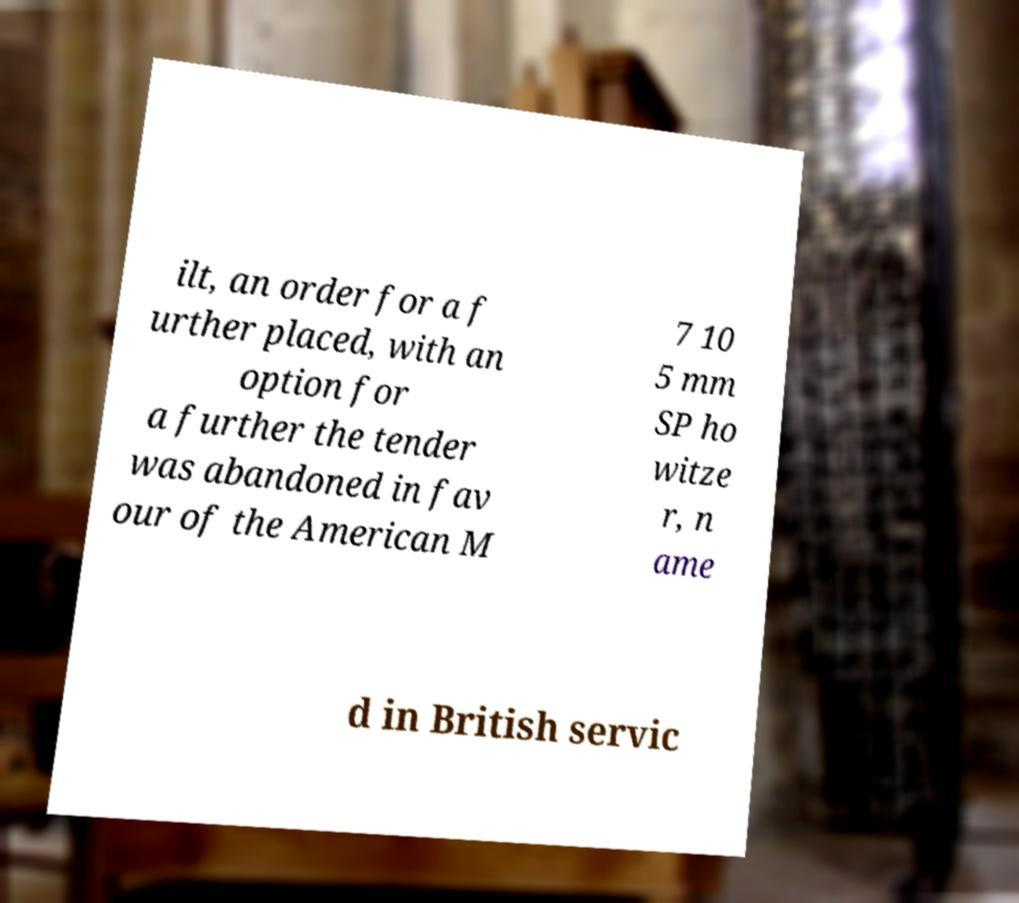Could you extract and type out the text from this image? ilt, an order for a f urther placed, with an option for a further the tender was abandoned in fav our of the American M 7 10 5 mm SP ho witze r, n ame d in British servic 